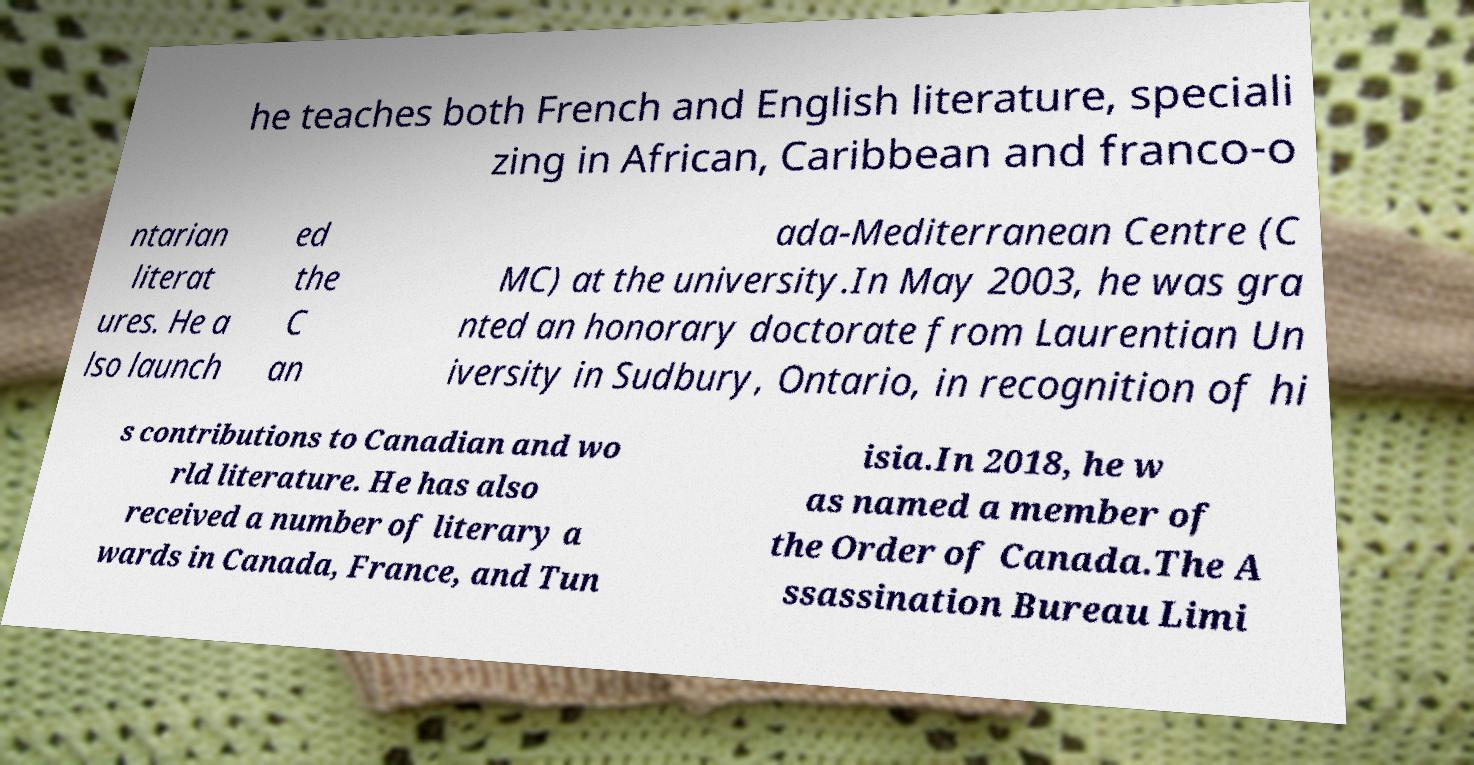Can you read and provide the text displayed in the image?This photo seems to have some interesting text. Can you extract and type it out for me? he teaches both French and English literature, speciali zing in African, Caribbean and franco-o ntarian literat ures. He a lso launch ed the C an ada-Mediterranean Centre (C MC) at the university.In May 2003, he was gra nted an honorary doctorate from Laurentian Un iversity in Sudbury, Ontario, in recognition of hi s contributions to Canadian and wo rld literature. He has also received a number of literary a wards in Canada, France, and Tun isia.In 2018, he w as named a member of the Order of Canada.The A ssassination Bureau Limi 